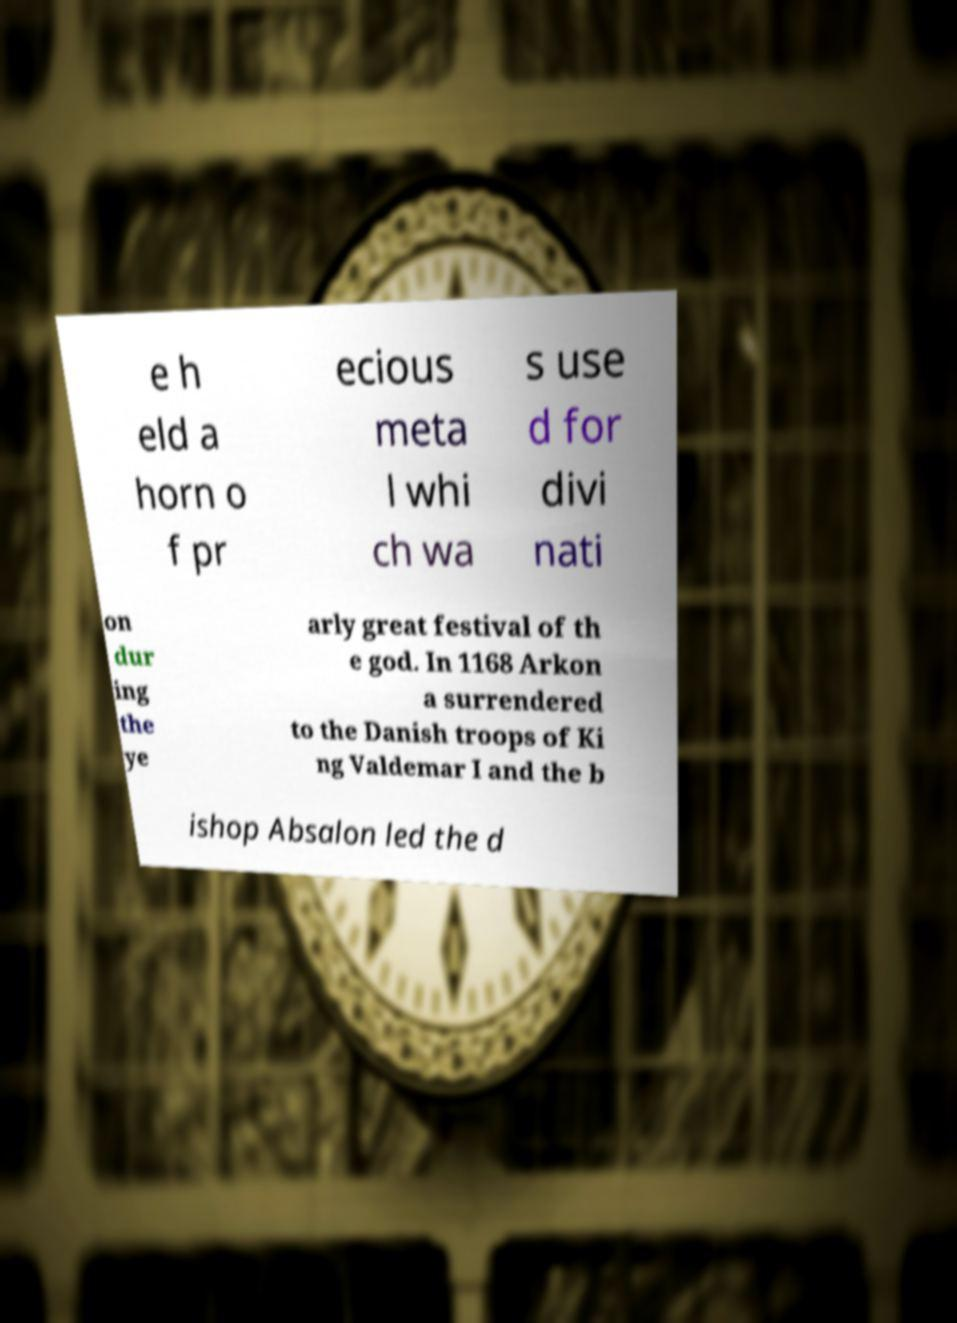I need the written content from this picture converted into text. Can you do that? e h eld a horn o f pr ecious meta l whi ch wa s use d for divi nati on dur ing the ye arly great festival of th e god. In 1168 Arkon a surrendered to the Danish troops of Ki ng Valdemar I and the b ishop Absalon led the d 